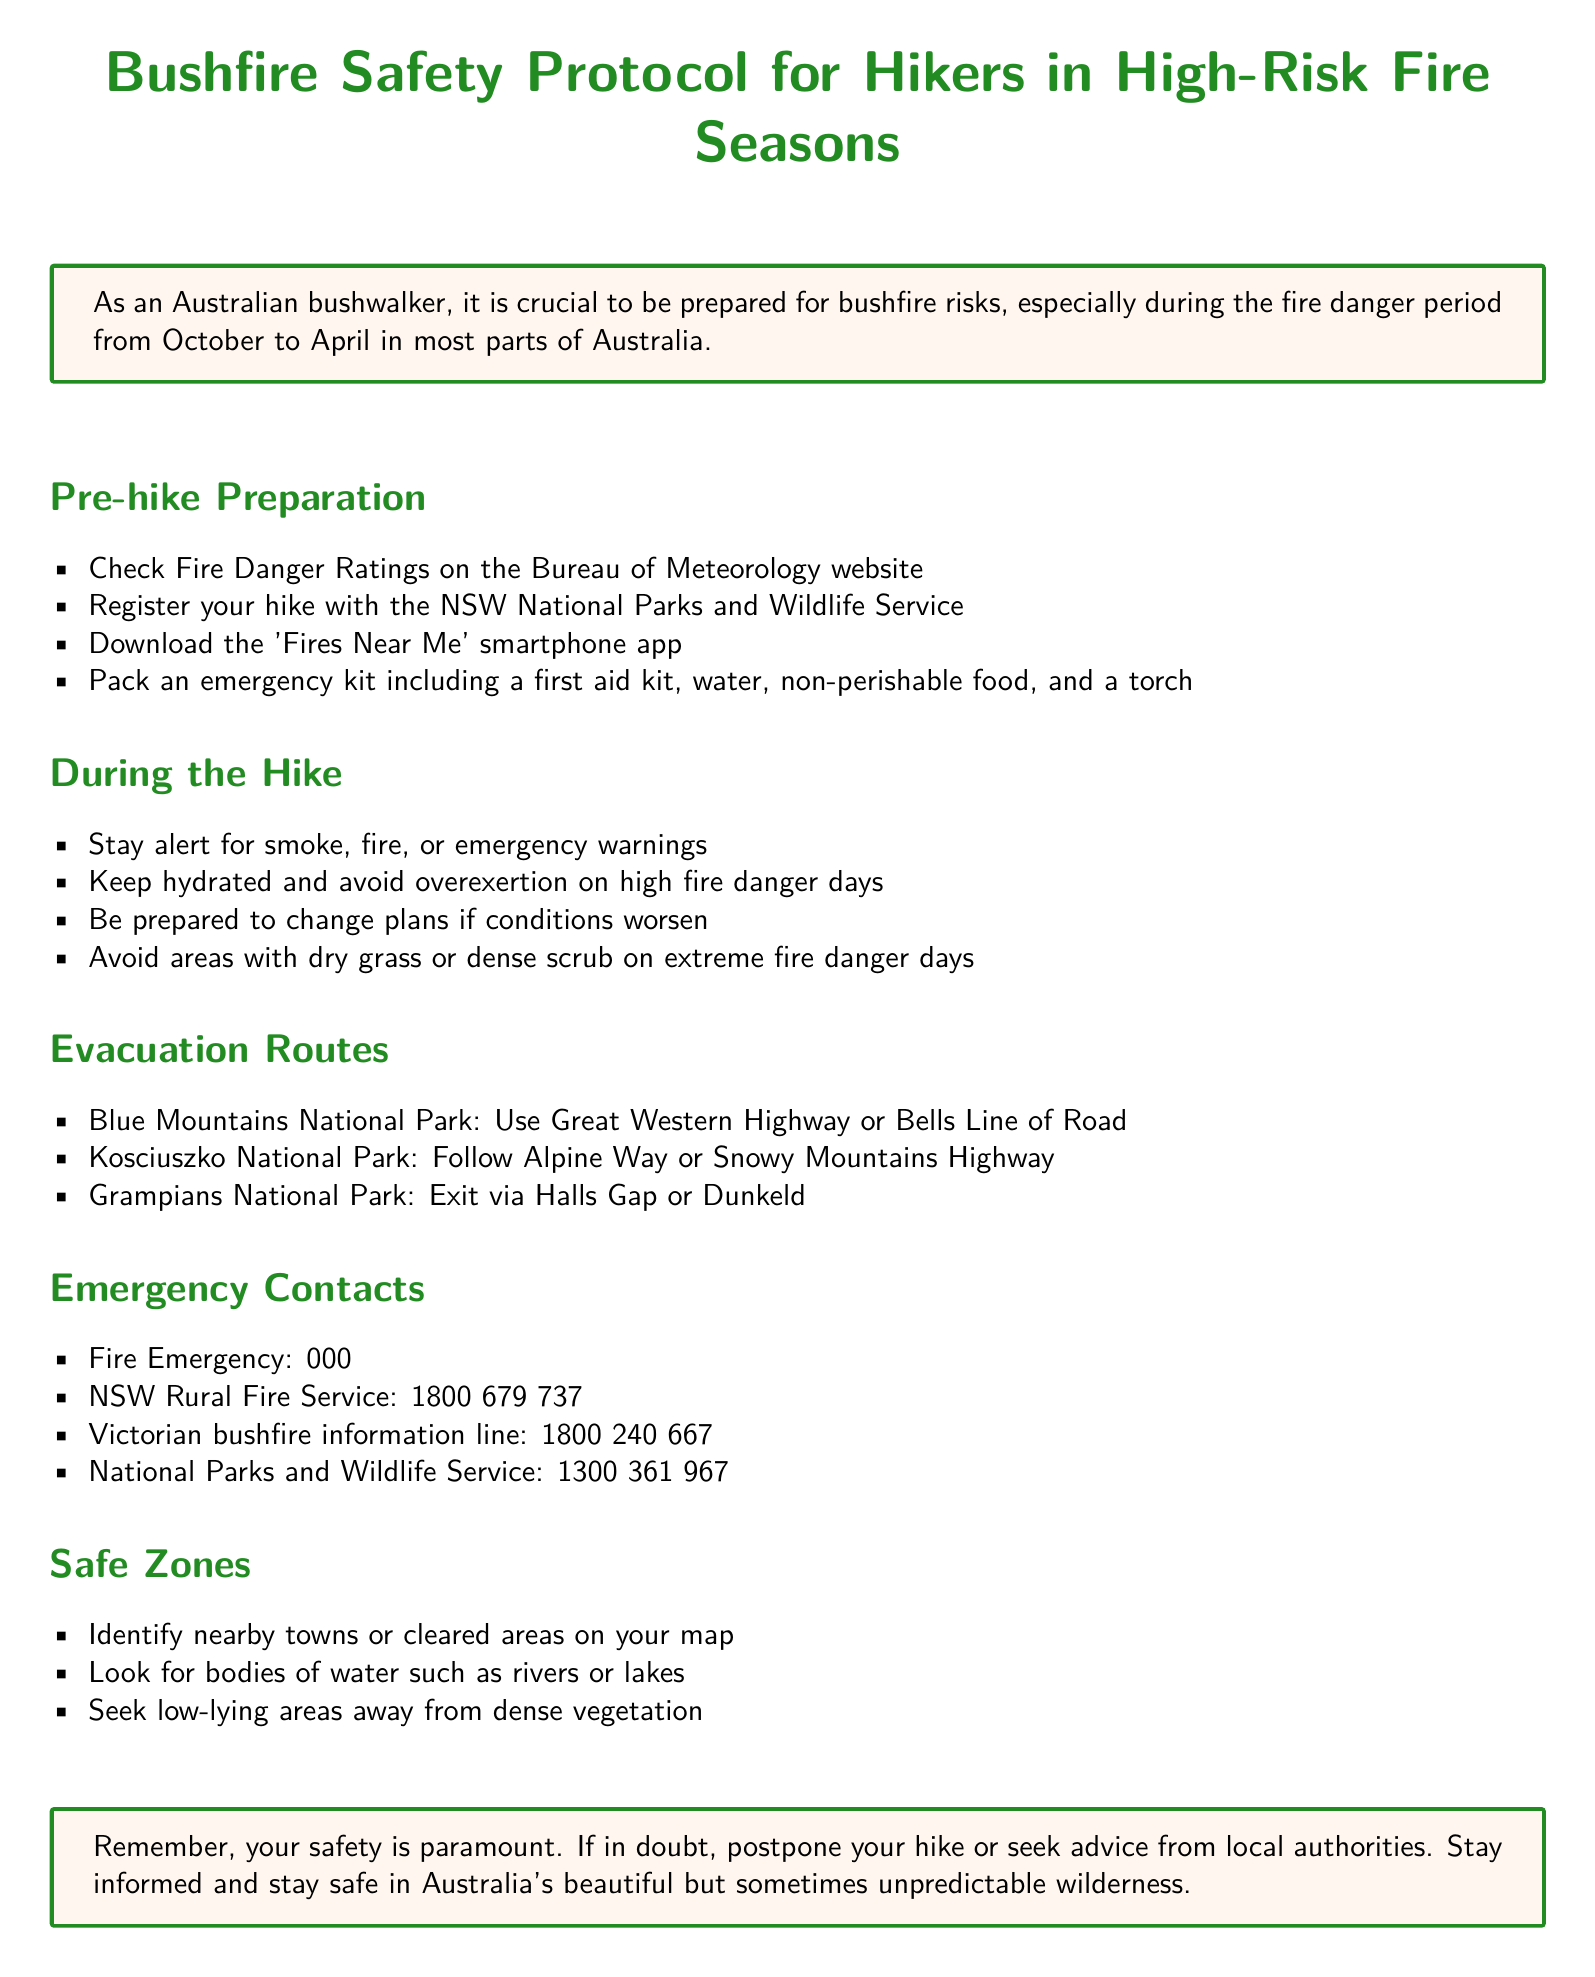What is the fire danger period? The fire danger period is specified in the document as occurring from October to April in most parts of Australia.
Answer: October to April What should you download before hiking? The document suggests downloading the 'Fires Near Me' smartphone app as part of pre-hike preparation.
Answer: 'Fires Near Me' smartphone app Which emergency contact number is for the fire emergency? The document provides the emergency number for fire emergencies, which is 000.
Answer: 000 What evacuation route is suggested for Blue Mountains National Park? The document specifically states the evacuation routes for Blue Mountains National Park as using the Great Western Highway or Bells Line of Road.
Answer: Great Western Highway or Bells Line of Road What should hikers avoid on extreme fire danger days? The document advises hikers to avoid areas with dry grass or dense scrub on extreme fire danger days.
Answer: Areas with dry grass or dense scrub How many emergency contacts are listed? Counting the items in the emergency contacts section of the document, there are four distinct emergency contact numbers provided.
Answer: Four What are safe zones to look for in case of a bushfire? The document indicates that hikers should identify nearby towns, cleared areas, bodies of water, and low-lying areas as safe zones.
Answer: Nearby towns, cleared areas, bodies of water, low-lying areas What is recommended if hikers are in doubt about their hike? The document states that if hikers are in doubt, they should postpone their hike or seek advice from local authorities.
Answer: Postpone the hike or seek advice What is included in the emergency kit? The document mentions packing a first aid kit, water, non-perishable food, and a torch as part of the emergency kit for hikers.
Answer: First aid kit, water, non-perishable food, torch 